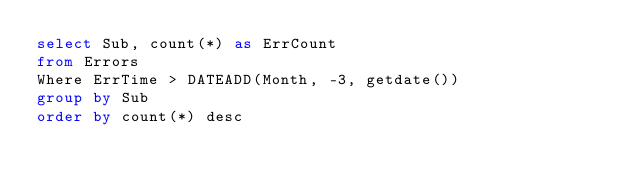Convert code to text. <code><loc_0><loc_0><loc_500><loc_500><_SQL_>select Sub, count(*) as ErrCount
from Errors
Where ErrTime > DATEADD(Month, -3, getdate())
group by Sub
order by count(*) desc</code> 